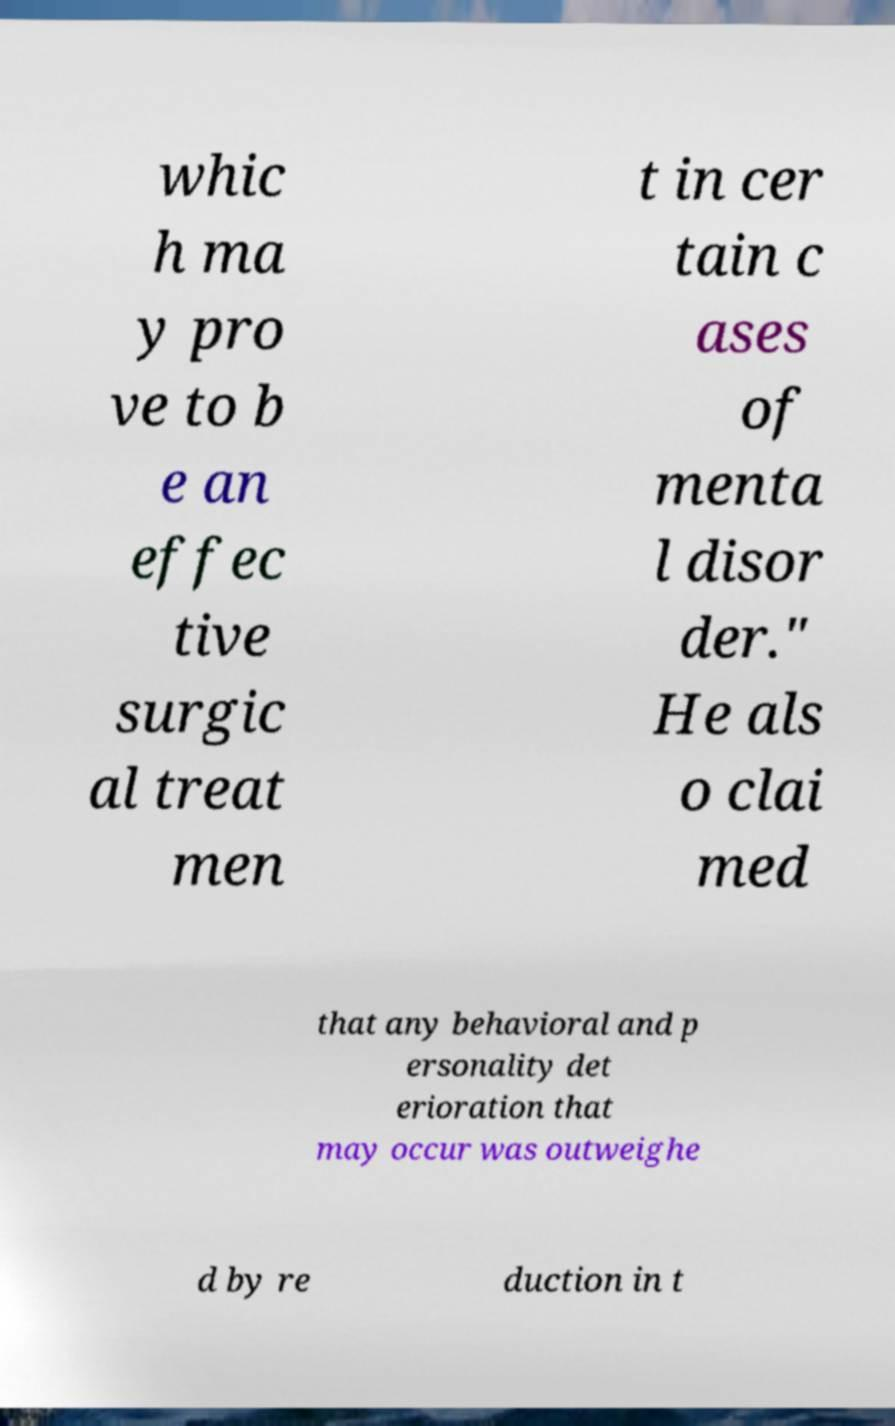Please identify and transcribe the text found in this image. whic h ma y pro ve to b e an effec tive surgic al treat men t in cer tain c ases of menta l disor der." He als o clai med that any behavioral and p ersonality det erioration that may occur was outweighe d by re duction in t 